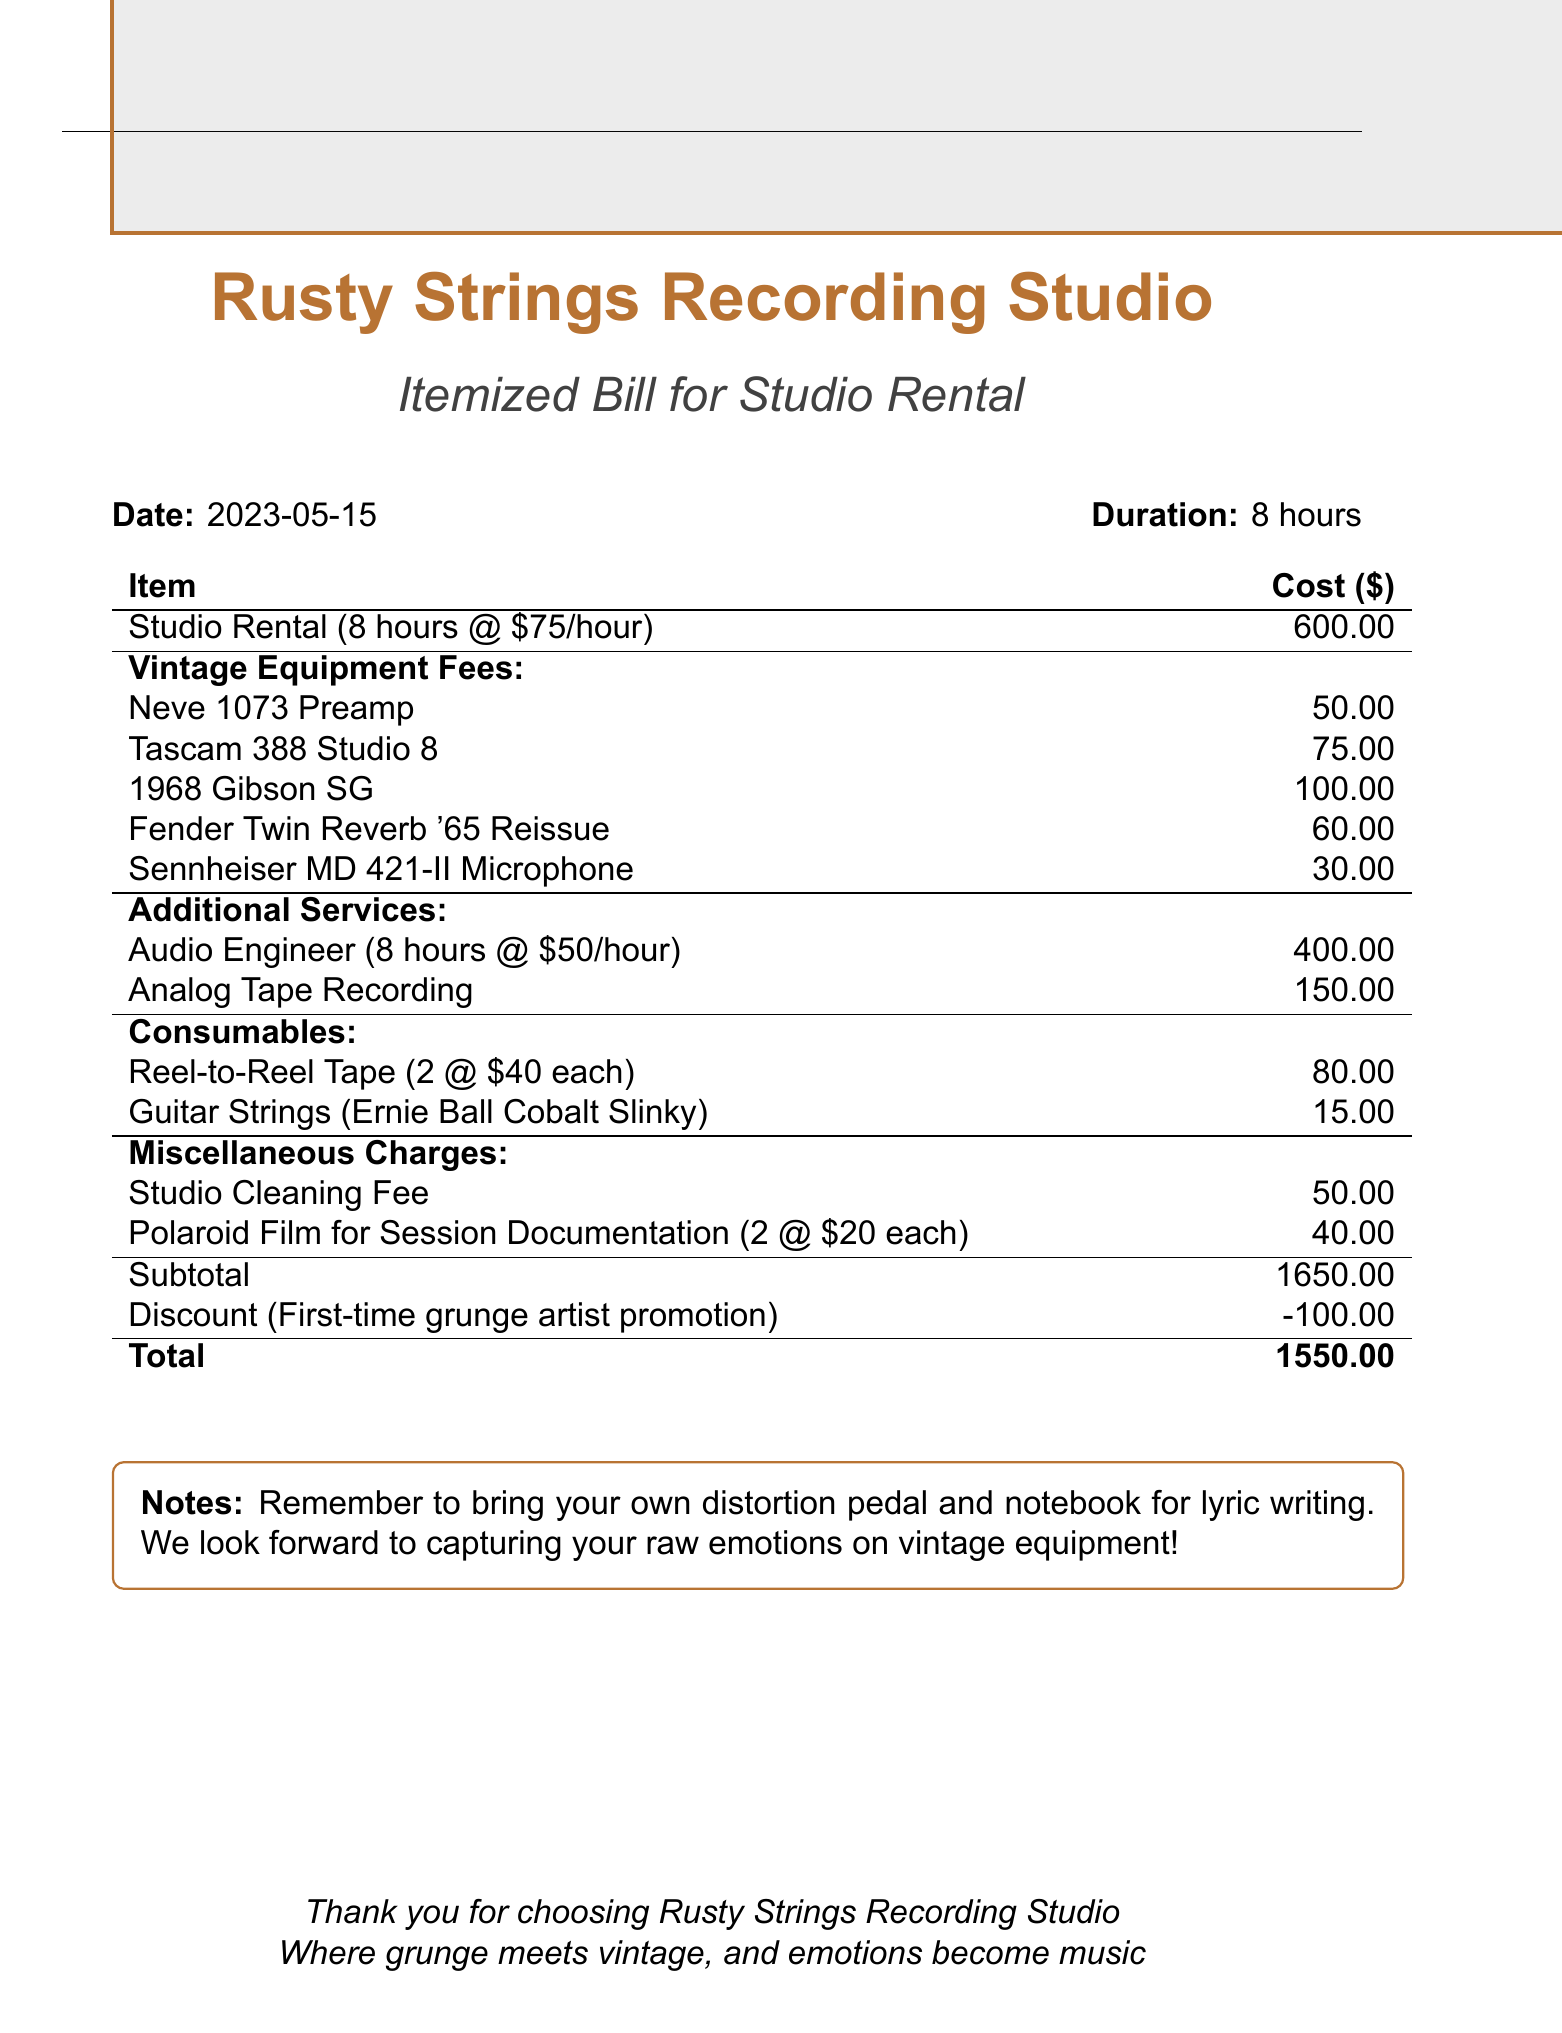What is the name of the studio? The studio's name is stated at the top of the document.
Answer: Rusty Strings Recording Studio What is the rental date? The rental date is provided in the header of the document.
Answer: 2023-05-15 How many hours was the studio rented? The rental duration is mentioned alongside the rental date.
Answer: 8 hours What is the fee for the Neve 1073 Preamp? The fee for each piece of vintage equipment is listed in the vintage equipment fees section.
Answer: 50 What is the total amount after the discount? The total is calculated by subtracting the discount from the subtotal shown in the document.
Answer: 1550 What type of additional service was provided by an audio engineer? Additional services and their respective descriptions are detailed in the document.
Answer: Audio Engineer What is the total charge for consumables? The consumables section lists individual prices, which should be summed to get the total.
Answer: 95 What is the reason for the discount? The document explicitly states the reason for the discount applicable on the total.
Answer: First-time grunge artist promotion How many Polaroid films were used for session documentation? This quantity is mentioned in the miscellaneous charges part of the document.
Answer: 2 What is suggested to bring for the session? The notes section specifically advises on items to bring for the recording session.
Answer: Distortion pedal and notebook 